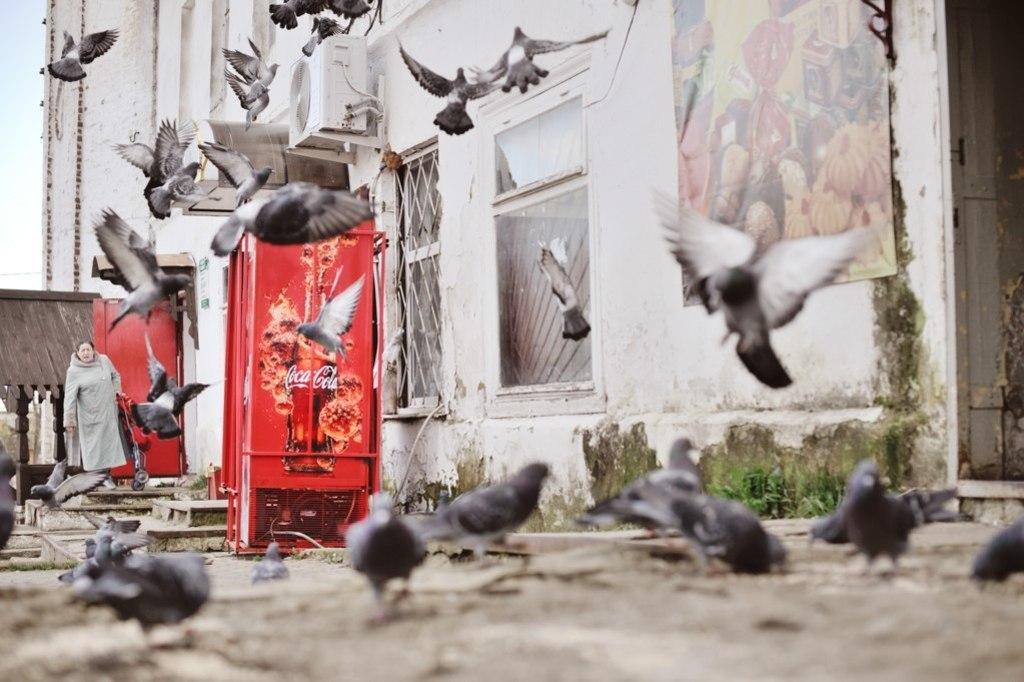How would you summarize this image in a sentence or two? In this image there are birds. On the left we can see a lady and a trolley. There are refrigerators. In the background there is a building, a poster, door and sky. 